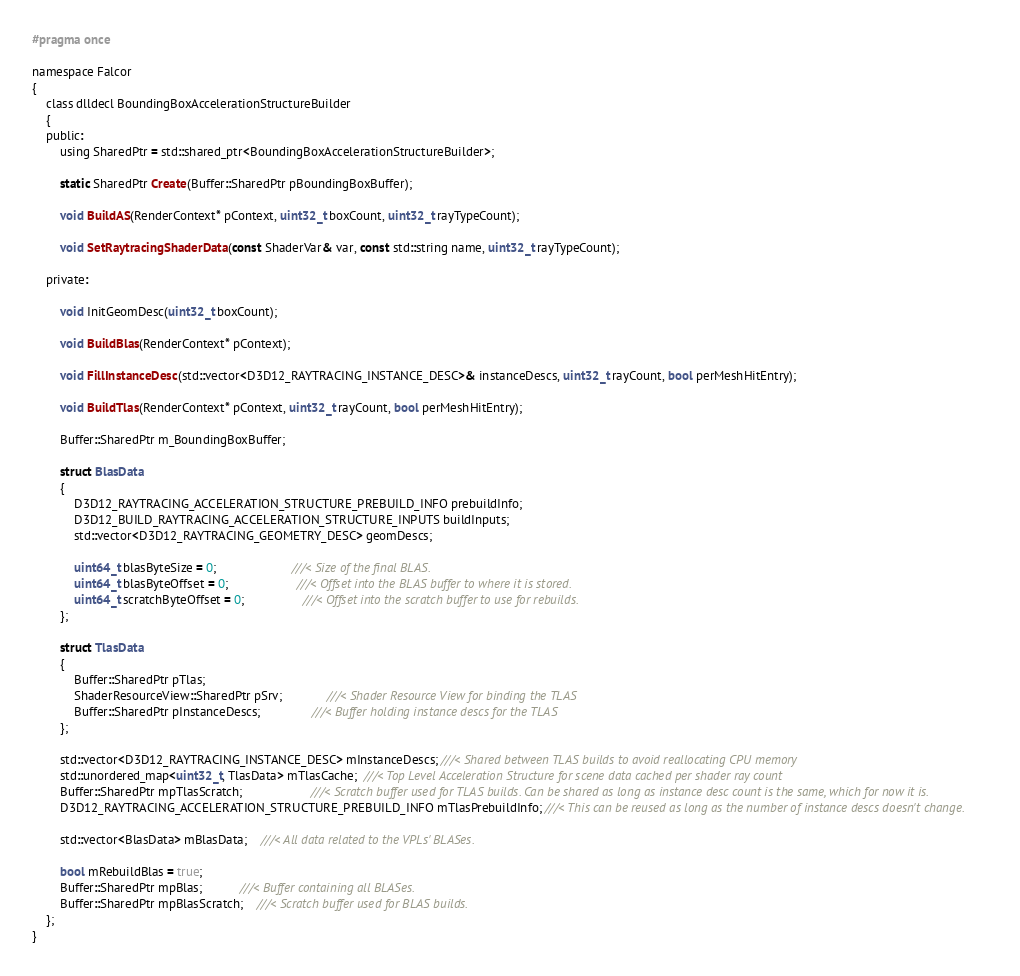<code> <loc_0><loc_0><loc_500><loc_500><_C_>#pragma once

namespace Falcor
{
    class dlldecl BoundingBoxAccelerationStructureBuilder
    {
    public:
        using SharedPtr = std::shared_ptr<BoundingBoxAccelerationStructureBuilder>;

        static SharedPtr Create(Buffer::SharedPtr pBoundingBoxBuffer);

        void BuildAS(RenderContext* pContext, uint32_t boxCount, uint32_t rayTypeCount);

        void SetRaytracingShaderData(const ShaderVar& var, const std::string name, uint32_t rayTypeCount);

    private:

        void InitGeomDesc(uint32_t boxCount);

        void BuildBlas(RenderContext* pContext);

        void FillInstanceDesc(std::vector<D3D12_RAYTRACING_INSTANCE_DESC>& instanceDescs, uint32_t rayCount, bool perMeshHitEntry);

        void BuildTlas(RenderContext* pContext, uint32_t rayCount, bool perMeshHitEntry);

        Buffer::SharedPtr m_BoundingBoxBuffer;

        struct BlasData
        {
            D3D12_RAYTRACING_ACCELERATION_STRUCTURE_PREBUILD_INFO prebuildInfo;
            D3D12_BUILD_RAYTRACING_ACCELERATION_STRUCTURE_INPUTS buildInputs;
            std::vector<D3D12_RAYTRACING_GEOMETRY_DESC> geomDescs;

            uint64_t blasByteSize = 0;                      ///< Size of the final BLAS.
            uint64_t blasByteOffset = 0;                    ///< Offset into the BLAS buffer to where it is stored.
            uint64_t scratchByteOffset = 0;                 ///< Offset into the scratch buffer to use for rebuilds.
        };

        struct TlasData
        {
            Buffer::SharedPtr pTlas;
            ShaderResourceView::SharedPtr pSrv;             ///< Shader Resource View for binding the TLAS
            Buffer::SharedPtr pInstanceDescs;               ///< Buffer holding instance descs for the TLAS
        };

        std::vector<D3D12_RAYTRACING_INSTANCE_DESC> mInstanceDescs; ///< Shared between TLAS builds to avoid reallocating CPU memory
        std::unordered_map<uint32_t, TlasData> mTlasCache;  ///< Top Level Acceleration Structure for scene data cached per shader ray count
        Buffer::SharedPtr mpTlasScratch;                    ///< Scratch buffer used for TLAS builds. Can be shared as long as instance desc count is the same, which for now it is.
        D3D12_RAYTRACING_ACCELERATION_STRUCTURE_PREBUILD_INFO mTlasPrebuildInfo; ///< This can be reused as long as the number of instance descs doesn't change.

        std::vector<BlasData> mBlasData;    ///< All data related to the VPLs' BLASes.

        bool mRebuildBlas = true;
        Buffer::SharedPtr mpBlas;           ///< Buffer containing all BLASes.
        Buffer::SharedPtr mpBlasScratch;    ///< Scratch buffer used for BLAS builds.
    };
}
</code> 